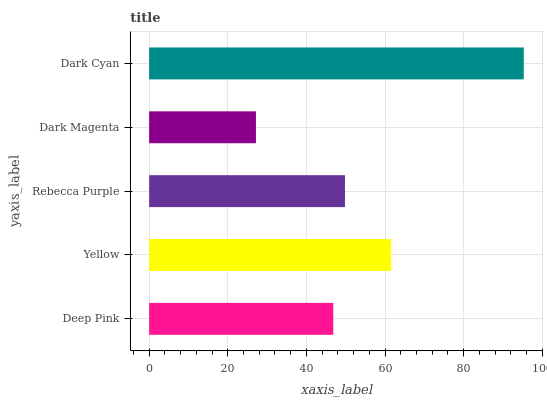Is Dark Magenta the minimum?
Answer yes or no. Yes. Is Dark Cyan the maximum?
Answer yes or no. Yes. Is Yellow the minimum?
Answer yes or no. No. Is Yellow the maximum?
Answer yes or no. No. Is Yellow greater than Deep Pink?
Answer yes or no. Yes. Is Deep Pink less than Yellow?
Answer yes or no. Yes. Is Deep Pink greater than Yellow?
Answer yes or no. No. Is Yellow less than Deep Pink?
Answer yes or no. No. Is Rebecca Purple the high median?
Answer yes or no. Yes. Is Rebecca Purple the low median?
Answer yes or no. Yes. Is Yellow the high median?
Answer yes or no. No. Is Yellow the low median?
Answer yes or no. No. 